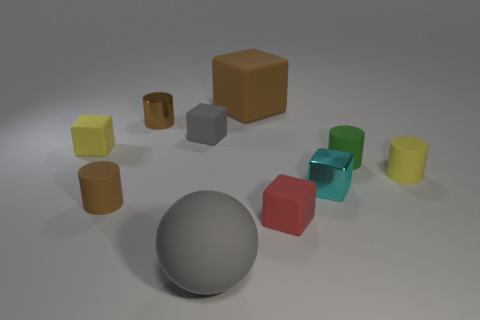How many cylinders are there?
Ensure brevity in your answer.  4. How many metal objects are big green cylinders or red cubes?
Offer a terse response. 0. How many matte things are the same color as the large ball?
Your answer should be very brief. 1. There is a yellow object to the left of the brown matte object that is behind the green cylinder; what is it made of?
Offer a very short reply. Rubber. What is the size of the yellow rubber cylinder?
Offer a very short reply. Small. What number of yellow rubber cylinders are the same size as the shiny cylinder?
Keep it short and to the point. 1. What number of red shiny objects are the same shape as the green object?
Provide a short and direct response. 0. Is the number of yellow cylinders that are left of the gray sphere the same as the number of green matte cylinders?
Offer a terse response. No. Is there anything else that has the same size as the brown block?
Your answer should be very brief. Yes. The rubber thing that is the same size as the brown matte cube is what shape?
Give a very brief answer. Sphere. 